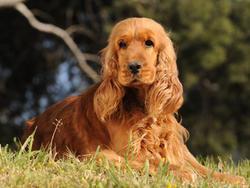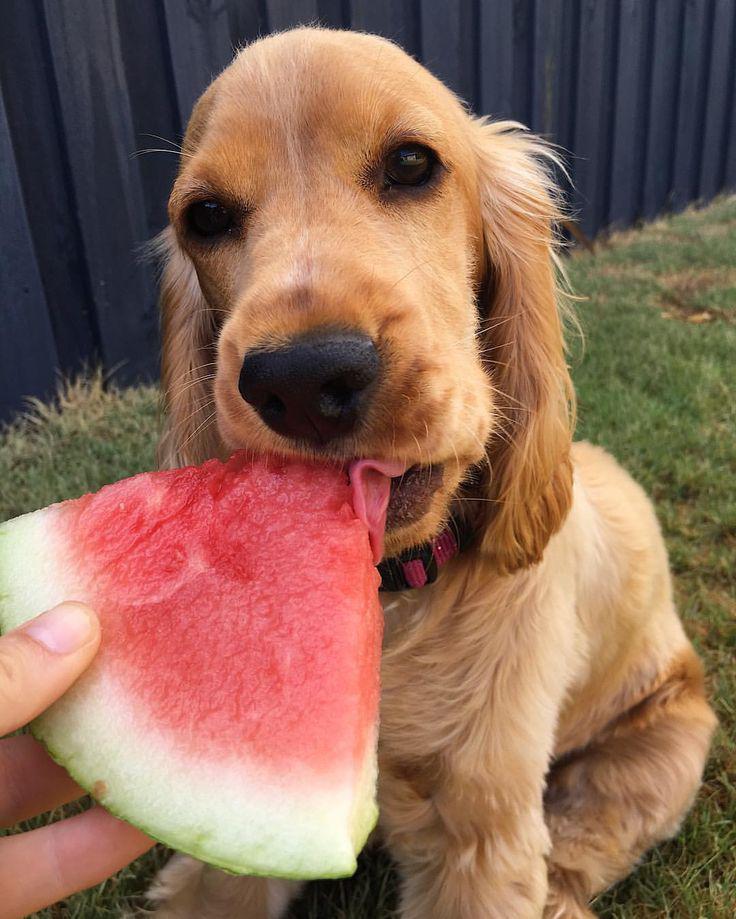The first image is the image on the left, the second image is the image on the right. For the images shown, is this caption "A spaniel dog is chewing on some object in one of the images." true? Answer yes or no. Yes. 